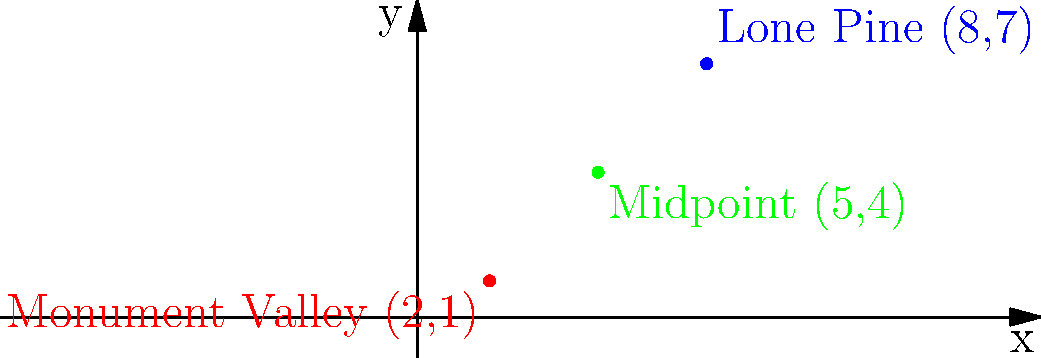Two iconic Western movie locations, Monument Valley and Lone Pine, are plotted on a coordinate plane. Monument Valley is located at (2,1), while Lone Pine is at (8,7). As a film festival programmer, you want to find a location equidistant from both sites for a special screening event. Calculate the coordinates of the midpoint between these two famous Western movie sets. To find the midpoint between two points, we use the midpoint formula:

$$ \text{Midpoint} = (\frac{x_1 + x_2}{2}, \frac{y_1 + y_2}{2}) $$

Where $(x_1, y_1)$ is the coordinate of the first point and $(x_2, y_2)$ is the coordinate of the second point.

Step 1: Identify the coordinates
Monument Valley: $(x_1, y_1) = (2, 1)$
Lone Pine: $(x_2, y_2) = (8, 7)$

Step 2: Calculate the x-coordinate of the midpoint
$$ x = \frac{x_1 + x_2}{2} = \frac{2 + 8}{2} = \frac{10}{2} = 5 $$

Step 3: Calculate the y-coordinate of the midpoint
$$ y = \frac{y_1 + y_2}{2} = \frac{1 + 7}{2} = \frac{8}{2} = 4 $$

Step 4: Combine the results
The midpoint coordinates are (5, 4).
Answer: (5, 4) 